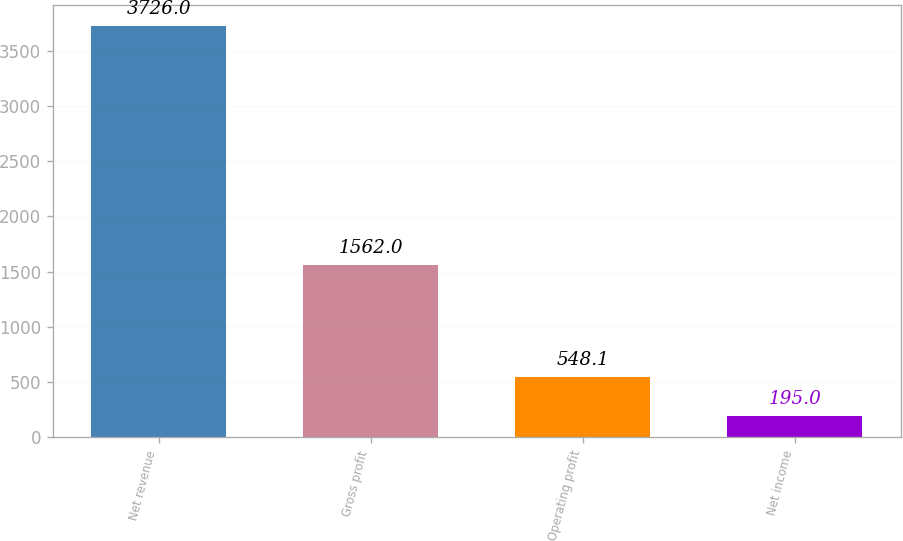<chart> <loc_0><loc_0><loc_500><loc_500><bar_chart><fcel>Net revenue<fcel>Gross profit<fcel>Operating profit<fcel>Net income<nl><fcel>3726<fcel>1562<fcel>548.1<fcel>195<nl></chart> 